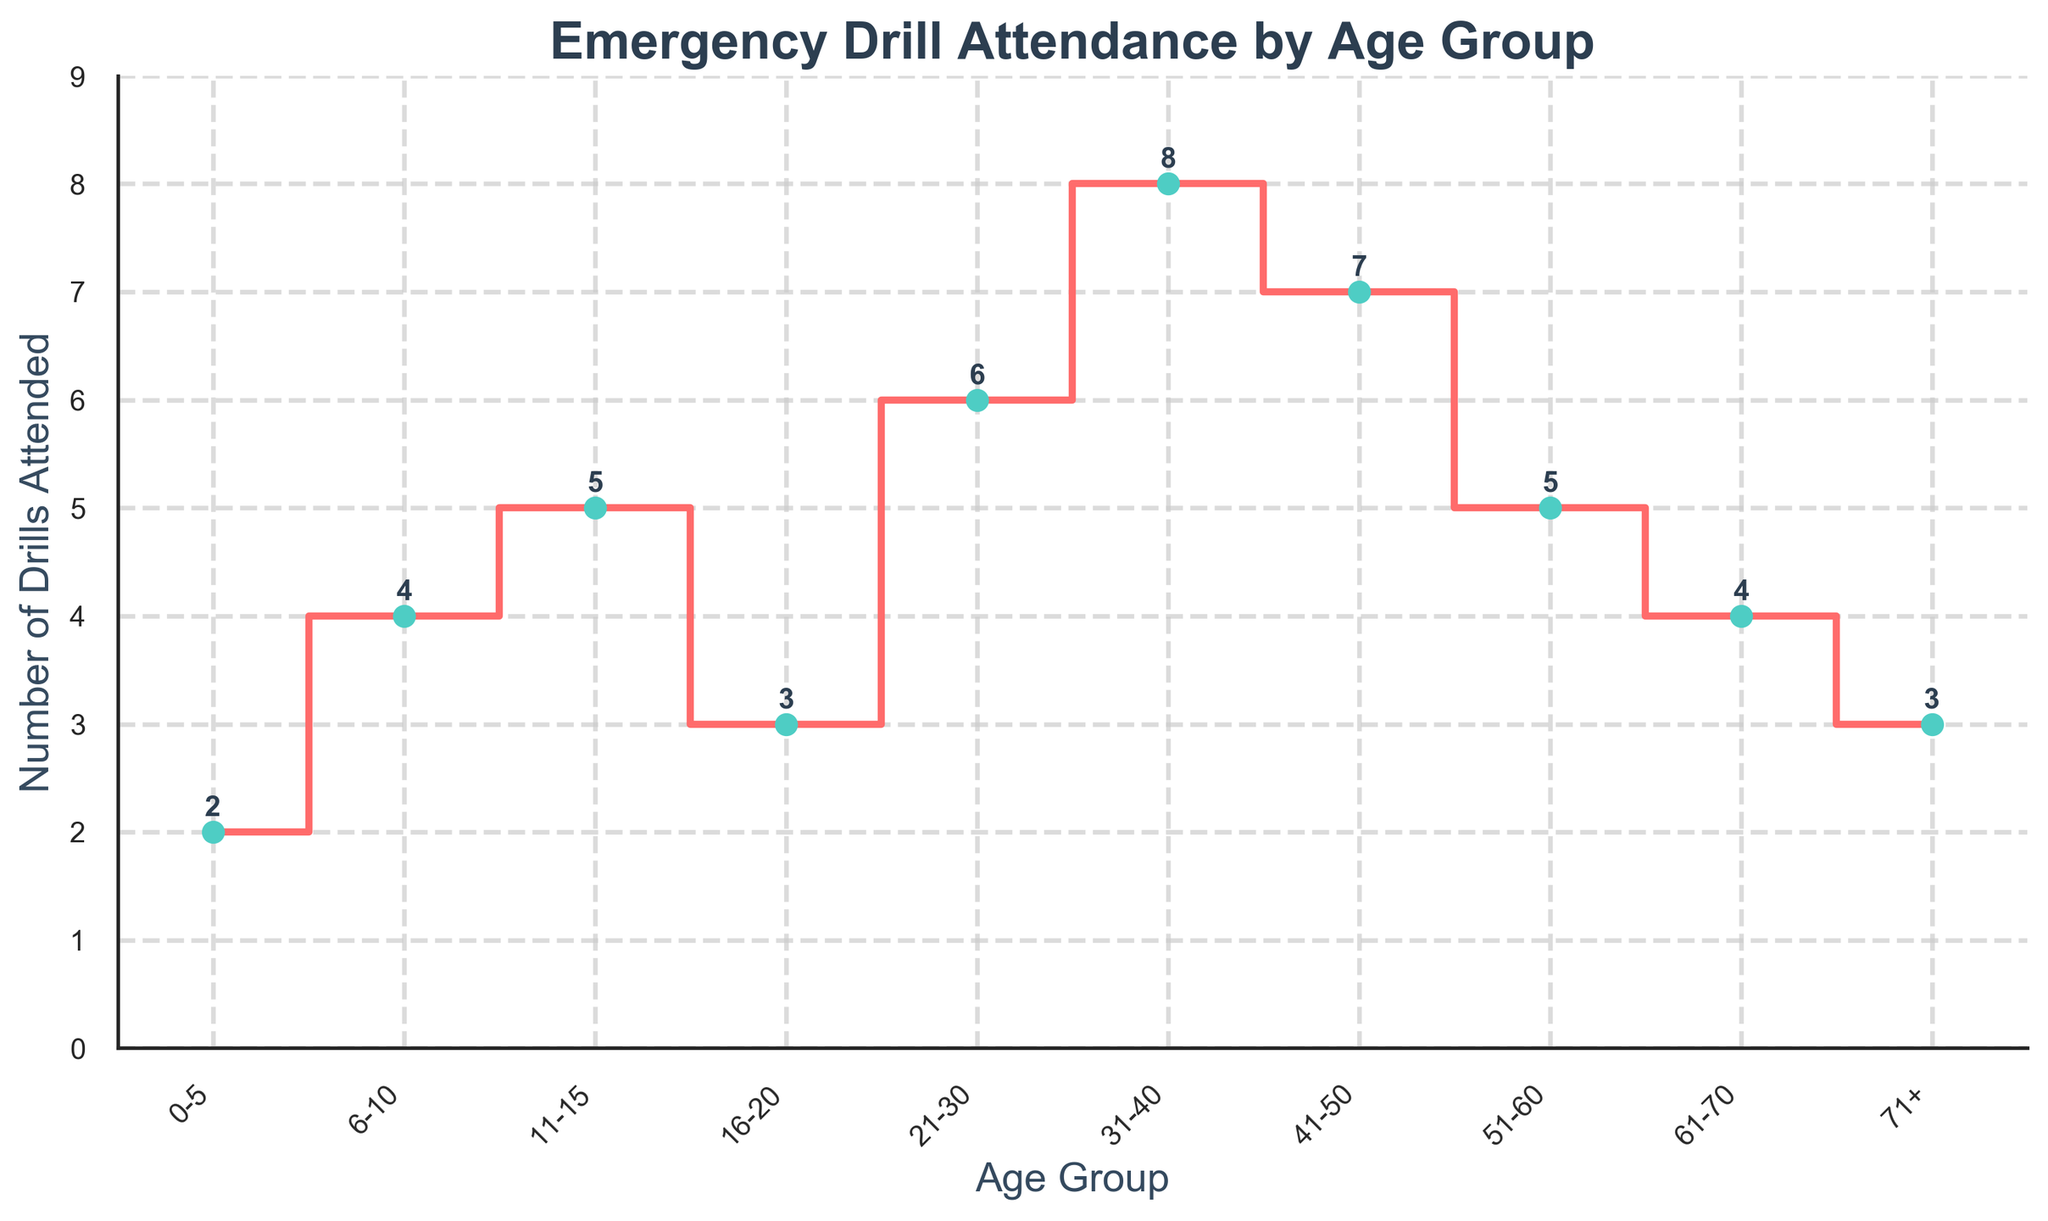What is the title of the plot? The title of the plot is displayed at the top and gives an overview of what the plot represents.
Answer: Emergency Drill Attendance by Age Group Which age group attended the most emergency drills? By visually inspecting the y-axis values, the age group with the highest number correlates with the tallest bar.
Answer: 31-40 How many emergency drills did the 16-20 age group attend? Locate the 16-20 age group on the x-axis and then trace vertically to find the corresponding y-axis value.
Answer: 3 What is the difference in the number of drills attended between the 0-5 and 6-10 age groups? Find the y-values for both 0-5 and 6-10 age groups and then compute the difference. 4 - 2 = 2
Answer: 2 Which age groups attended an equal number of emergency drills? Identify age groups with the same y-axis value and cross-check for accuracy.
Answer: 11-15 and 51-60; 6-10 and 61-70; 16-20 and 71+ What is the total number of drills attended by all age groups combined? Sum up all the y-values across the age groups. 2 + 4 + 5 + 3 + 6 + 8 + 7 + 5 + 4 + 3 = 47
Answer: 47 How many age groups attended more than 5 emergency drills? Identify the age groups with y-values greater than 5 and count them.
Answer: 3 What is the median number of drills attended by all age groups? Arrange the y-values in ascending order and find the middle value. 2, 3, 3, 4, 4, 5, 5, 6, 7, 8; since the number of groups is even (10), the median would be the average of the 5th and 6th values (4 and 5), so (4+5) / 2 = 4.5
Answer: 4.5 Is there a trend in drill attendance based on age? Inspect the plot and observe general patterns, such as increasing, decreasing, or fluctuating attendance based on age groups.
Answer: No clear trend What age group had the least variation in drill attendance compared to its neighboring groups? Examine the differences in values between neighboring age groups and identify the smallest variation.
Answer: 16-20 (difference with both previous 11-15 and next 21-30 is 2) 